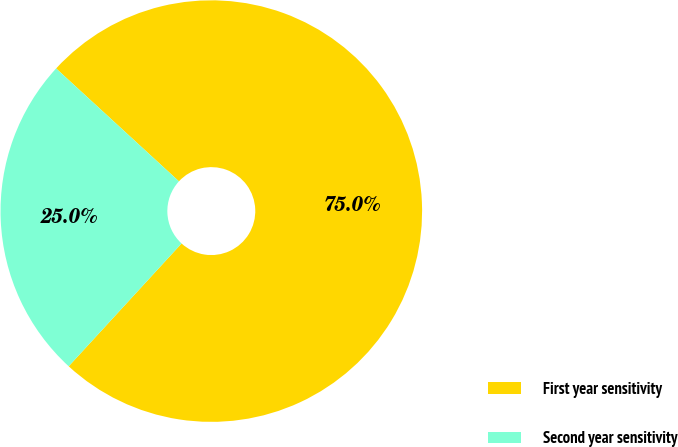Convert chart to OTSL. <chart><loc_0><loc_0><loc_500><loc_500><pie_chart><fcel>First year sensitivity<fcel>Second year sensitivity<nl><fcel>75.0%<fcel>25.0%<nl></chart> 